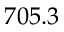<formula> <loc_0><loc_0><loc_500><loc_500>7 0 5 . 3</formula> 